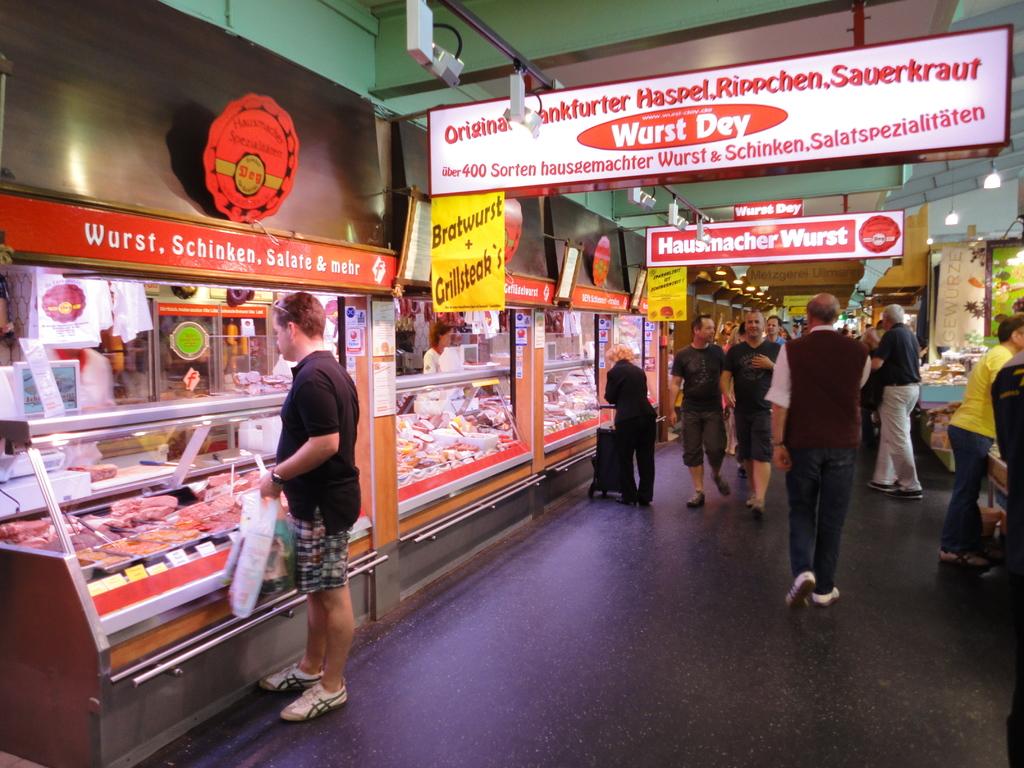What does it say on the yellow sign on the left?
Offer a very short reply. Bratwurst + grillsteak's. 